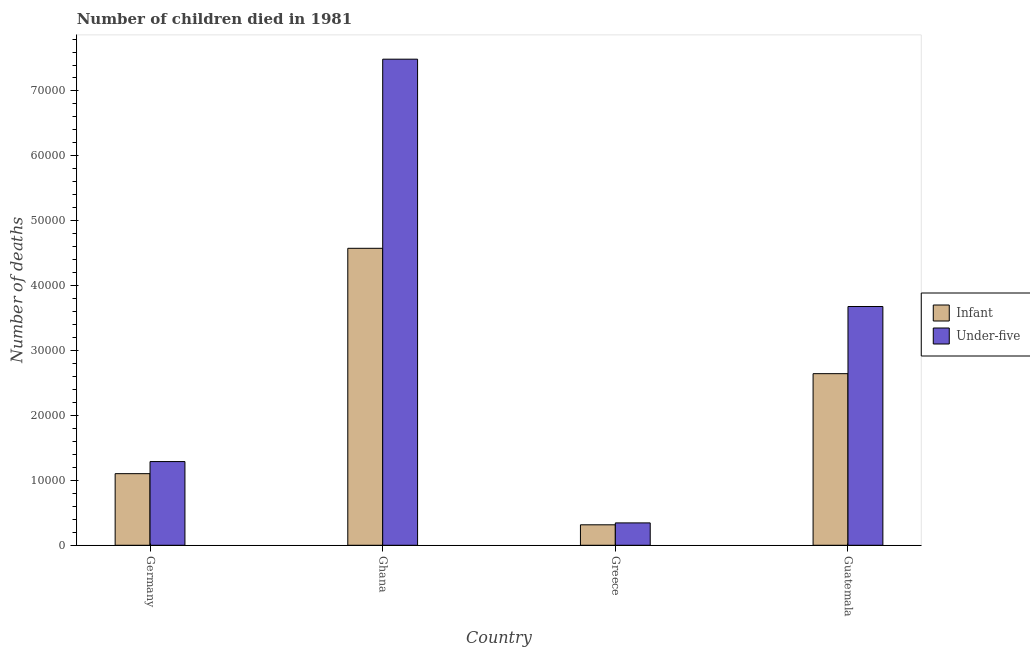Are the number of bars on each tick of the X-axis equal?
Provide a succinct answer. Yes. How many bars are there on the 1st tick from the left?
Your response must be concise. 2. How many bars are there on the 4th tick from the right?
Ensure brevity in your answer.  2. What is the label of the 4th group of bars from the left?
Make the answer very short. Guatemala. In how many cases, is the number of bars for a given country not equal to the number of legend labels?
Provide a short and direct response. 0. What is the number of infant deaths in Ghana?
Ensure brevity in your answer.  4.58e+04. Across all countries, what is the maximum number of infant deaths?
Keep it short and to the point. 4.58e+04. Across all countries, what is the minimum number of infant deaths?
Ensure brevity in your answer.  3154. In which country was the number of infant deaths minimum?
Give a very brief answer. Greece. What is the total number of infant deaths in the graph?
Your response must be concise. 8.64e+04. What is the difference between the number of under-five deaths in Greece and that in Guatemala?
Offer a very short reply. -3.33e+04. What is the difference between the number of under-five deaths in Ghana and the number of infant deaths in Germany?
Your answer should be very brief. 6.39e+04. What is the average number of infant deaths per country?
Your response must be concise. 2.16e+04. What is the difference between the number of under-five deaths and number of infant deaths in Ghana?
Offer a very short reply. 2.91e+04. What is the ratio of the number of under-five deaths in Ghana to that in Guatemala?
Offer a terse response. 2.04. Is the number of under-five deaths in Greece less than that in Guatemala?
Provide a short and direct response. Yes. What is the difference between the highest and the second highest number of under-five deaths?
Your answer should be very brief. 3.81e+04. What is the difference between the highest and the lowest number of infant deaths?
Keep it short and to the point. 4.26e+04. In how many countries, is the number of under-five deaths greater than the average number of under-five deaths taken over all countries?
Make the answer very short. 2. Is the sum of the number of under-five deaths in Ghana and Guatemala greater than the maximum number of infant deaths across all countries?
Keep it short and to the point. Yes. What does the 2nd bar from the left in Germany represents?
Your answer should be very brief. Under-five. What does the 2nd bar from the right in Greece represents?
Give a very brief answer. Infant. Are all the bars in the graph horizontal?
Keep it short and to the point. No. How many countries are there in the graph?
Give a very brief answer. 4. What is the difference between two consecutive major ticks on the Y-axis?
Your response must be concise. 10000. Are the values on the major ticks of Y-axis written in scientific E-notation?
Your answer should be compact. No. Does the graph contain any zero values?
Your answer should be very brief. No. Does the graph contain grids?
Keep it short and to the point. No. Where does the legend appear in the graph?
Give a very brief answer. Center right. How many legend labels are there?
Offer a very short reply. 2. How are the legend labels stacked?
Your answer should be compact. Vertical. What is the title of the graph?
Your response must be concise. Number of children died in 1981. Does "Urban Population" appear as one of the legend labels in the graph?
Keep it short and to the point. No. What is the label or title of the Y-axis?
Give a very brief answer. Number of deaths. What is the Number of deaths in Infant in Germany?
Give a very brief answer. 1.10e+04. What is the Number of deaths of Under-five in Germany?
Offer a terse response. 1.29e+04. What is the Number of deaths of Infant in Ghana?
Ensure brevity in your answer.  4.58e+04. What is the Number of deaths in Under-five in Ghana?
Your answer should be compact. 7.49e+04. What is the Number of deaths of Infant in Greece?
Your answer should be very brief. 3154. What is the Number of deaths of Under-five in Greece?
Keep it short and to the point. 3447. What is the Number of deaths of Infant in Guatemala?
Your answer should be very brief. 2.64e+04. What is the Number of deaths of Under-five in Guatemala?
Provide a succinct answer. 3.68e+04. Across all countries, what is the maximum Number of deaths of Infant?
Provide a succinct answer. 4.58e+04. Across all countries, what is the maximum Number of deaths of Under-five?
Your answer should be very brief. 7.49e+04. Across all countries, what is the minimum Number of deaths in Infant?
Give a very brief answer. 3154. Across all countries, what is the minimum Number of deaths of Under-five?
Keep it short and to the point. 3447. What is the total Number of deaths of Infant in the graph?
Your answer should be very brief. 8.64e+04. What is the total Number of deaths of Under-five in the graph?
Offer a very short reply. 1.28e+05. What is the difference between the Number of deaths in Infant in Germany and that in Ghana?
Offer a terse response. -3.47e+04. What is the difference between the Number of deaths in Under-five in Germany and that in Ghana?
Provide a succinct answer. -6.20e+04. What is the difference between the Number of deaths in Infant in Germany and that in Greece?
Give a very brief answer. 7879. What is the difference between the Number of deaths in Under-five in Germany and that in Greece?
Offer a very short reply. 9449. What is the difference between the Number of deaths in Infant in Germany and that in Guatemala?
Your answer should be very brief. -1.54e+04. What is the difference between the Number of deaths of Under-five in Germany and that in Guatemala?
Your response must be concise. -2.39e+04. What is the difference between the Number of deaths in Infant in Ghana and that in Greece?
Your response must be concise. 4.26e+04. What is the difference between the Number of deaths of Under-five in Ghana and that in Greece?
Give a very brief answer. 7.14e+04. What is the difference between the Number of deaths of Infant in Ghana and that in Guatemala?
Provide a short and direct response. 1.93e+04. What is the difference between the Number of deaths of Under-five in Ghana and that in Guatemala?
Provide a short and direct response. 3.81e+04. What is the difference between the Number of deaths in Infant in Greece and that in Guatemala?
Provide a short and direct response. -2.33e+04. What is the difference between the Number of deaths of Under-five in Greece and that in Guatemala?
Make the answer very short. -3.33e+04. What is the difference between the Number of deaths of Infant in Germany and the Number of deaths of Under-five in Ghana?
Your answer should be very brief. -6.39e+04. What is the difference between the Number of deaths in Infant in Germany and the Number of deaths in Under-five in Greece?
Make the answer very short. 7586. What is the difference between the Number of deaths of Infant in Germany and the Number of deaths of Under-five in Guatemala?
Offer a terse response. -2.58e+04. What is the difference between the Number of deaths in Infant in Ghana and the Number of deaths in Under-five in Greece?
Give a very brief answer. 4.23e+04. What is the difference between the Number of deaths in Infant in Ghana and the Number of deaths in Under-five in Guatemala?
Provide a succinct answer. 8968. What is the difference between the Number of deaths of Infant in Greece and the Number of deaths of Under-five in Guatemala?
Your answer should be very brief. -3.36e+04. What is the average Number of deaths in Infant per country?
Make the answer very short. 2.16e+04. What is the average Number of deaths in Under-five per country?
Your answer should be very brief. 3.20e+04. What is the difference between the Number of deaths in Infant and Number of deaths in Under-five in Germany?
Make the answer very short. -1863. What is the difference between the Number of deaths in Infant and Number of deaths in Under-five in Ghana?
Your response must be concise. -2.91e+04. What is the difference between the Number of deaths in Infant and Number of deaths in Under-five in Greece?
Your answer should be very brief. -293. What is the difference between the Number of deaths of Infant and Number of deaths of Under-five in Guatemala?
Your response must be concise. -1.03e+04. What is the ratio of the Number of deaths of Infant in Germany to that in Ghana?
Give a very brief answer. 0.24. What is the ratio of the Number of deaths of Under-five in Germany to that in Ghana?
Your response must be concise. 0.17. What is the ratio of the Number of deaths in Infant in Germany to that in Greece?
Keep it short and to the point. 3.5. What is the ratio of the Number of deaths of Under-five in Germany to that in Greece?
Offer a very short reply. 3.74. What is the ratio of the Number of deaths of Infant in Germany to that in Guatemala?
Make the answer very short. 0.42. What is the ratio of the Number of deaths in Under-five in Germany to that in Guatemala?
Your response must be concise. 0.35. What is the ratio of the Number of deaths of Infant in Ghana to that in Greece?
Offer a very short reply. 14.51. What is the ratio of the Number of deaths of Under-five in Ghana to that in Greece?
Offer a very short reply. 21.73. What is the ratio of the Number of deaths of Infant in Ghana to that in Guatemala?
Keep it short and to the point. 1.73. What is the ratio of the Number of deaths of Under-five in Ghana to that in Guatemala?
Your response must be concise. 2.04. What is the ratio of the Number of deaths of Infant in Greece to that in Guatemala?
Provide a succinct answer. 0.12. What is the ratio of the Number of deaths in Under-five in Greece to that in Guatemala?
Offer a terse response. 0.09. What is the difference between the highest and the second highest Number of deaths in Infant?
Ensure brevity in your answer.  1.93e+04. What is the difference between the highest and the second highest Number of deaths of Under-five?
Keep it short and to the point. 3.81e+04. What is the difference between the highest and the lowest Number of deaths in Infant?
Ensure brevity in your answer.  4.26e+04. What is the difference between the highest and the lowest Number of deaths in Under-five?
Offer a very short reply. 7.14e+04. 